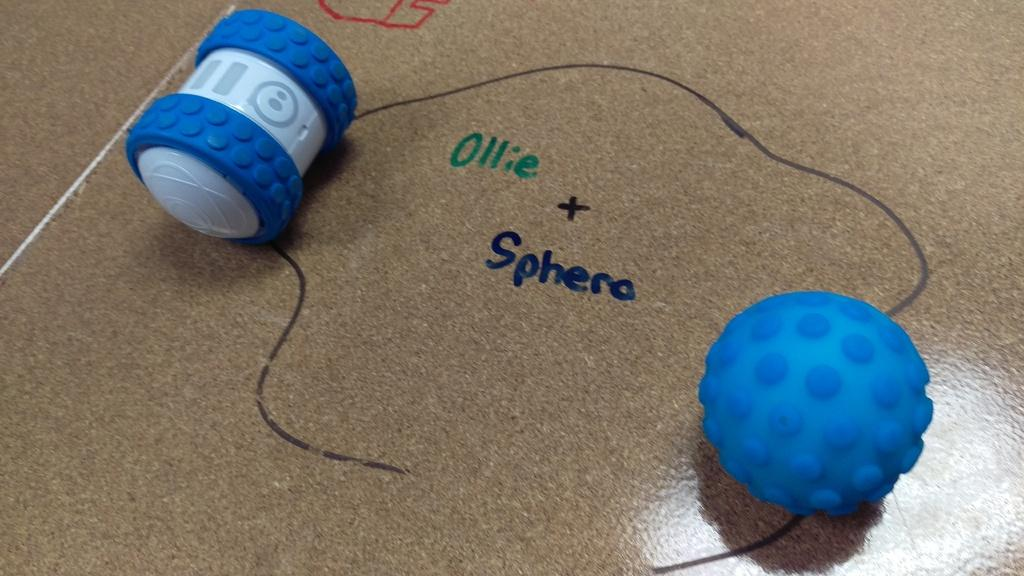<image>
Provide a brief description of the given image. A couple of toys placed on a surface that reads Ollie + Sphera. 